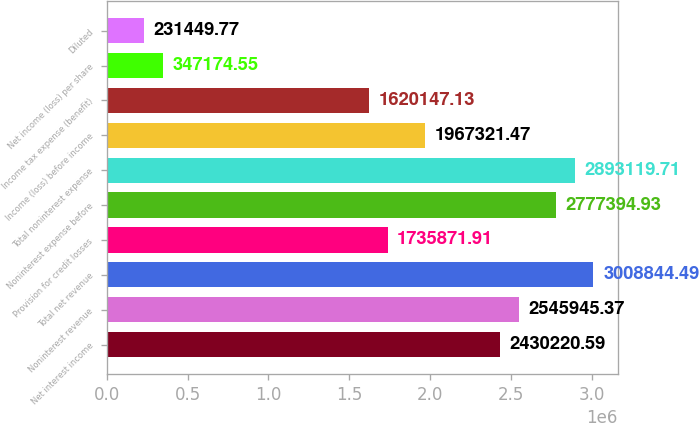Convert chart. <chart><loc_0><loc_0><loc_500><loc_500><bar_chart><fcel>Net interest income<fcel>Noninterest revenue<fcel>Total net revenue<fcel>Provision for credit losses<fcel>Noninterest expense before<fcel>Total noninterest expense<fcel>Income (loss) before income<fcel>Income tax expense (benefit)<fcel>Net income (loss) per share<fcel>Diluted<nl><fcel>2.43022e+06<fcel>2.54595e+06<fcel>3.00884e+06<fcel>1.73587e+06<fcel>2.77739e+06<fcel>2.89312e+06<fcel>1.96732e+06<fcel>1.62015e+06<fcel>347175<fcel>231450<nl></chart> 